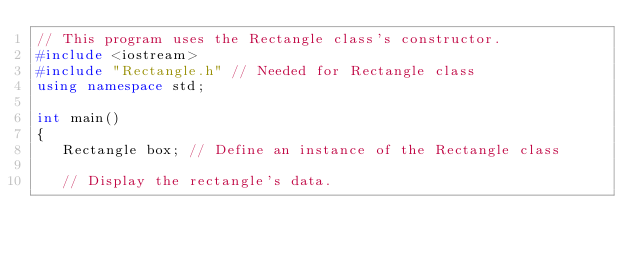Convert code to text. <code><loc_0><loc_0><loc_500><loc_500><_C++_>// This program uses the Rectangle class's constructor.
#include <iostream>
#include "Rectangle.h" // Needed for Rectangle class
using namespace std;

int main()
{
   Rectangle box; // Define an instance of the Rectangle class
   
   // Display the rectangle's data.</code> 